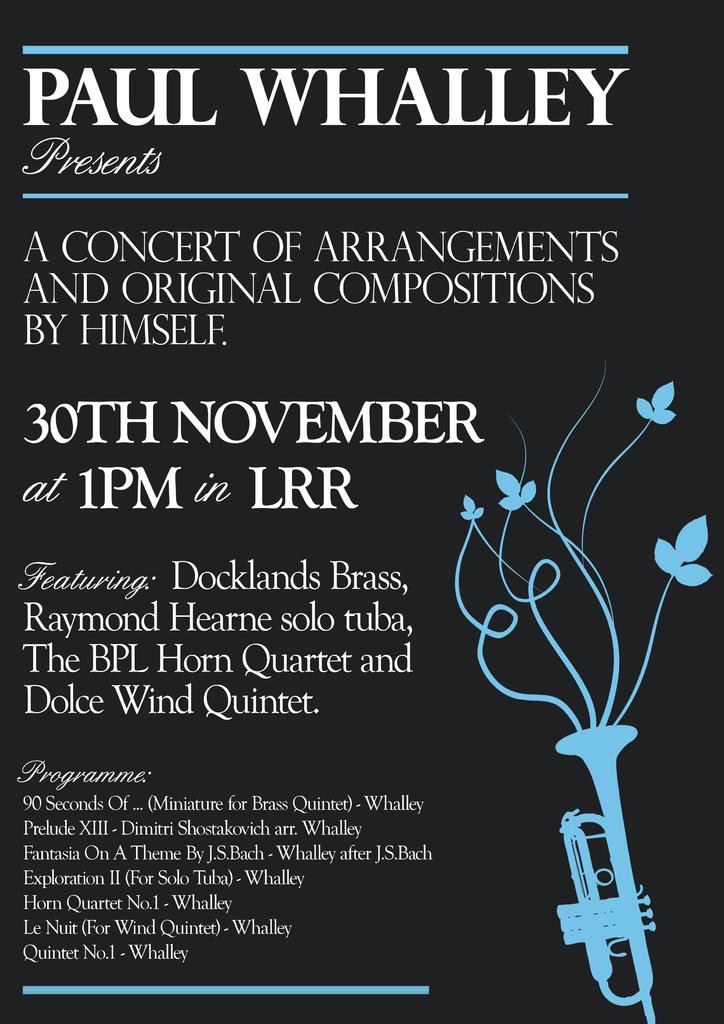What is the main object in the image? There is an invitation in the image. What colors are used for the invitation? The invitation is in black and blue color. What images are depicted on the invitation? There is a trumpet and flowers depicted on the invitation. Can you tell me how many times the word "copy" is mentioned on the invitation? There is no mention of the word "copy" on the invitation; it only contains images of a trumpet and flowers. Is there a snake depicted on the invitation? No, there is no snake depicted on the invitation; it only features a trumpet and flowers. 